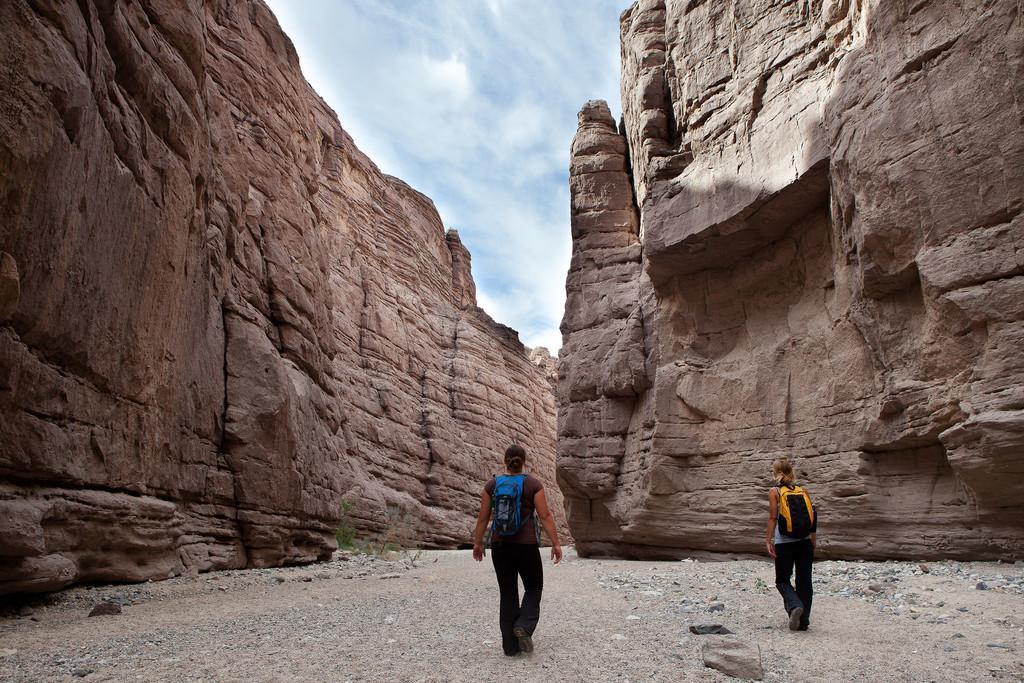Can you describe this image briefly? This image consists of two women walking. At the bottom, there is ground. In the background, there are mountains and rocks. At the top, there are clouds in the sky. 